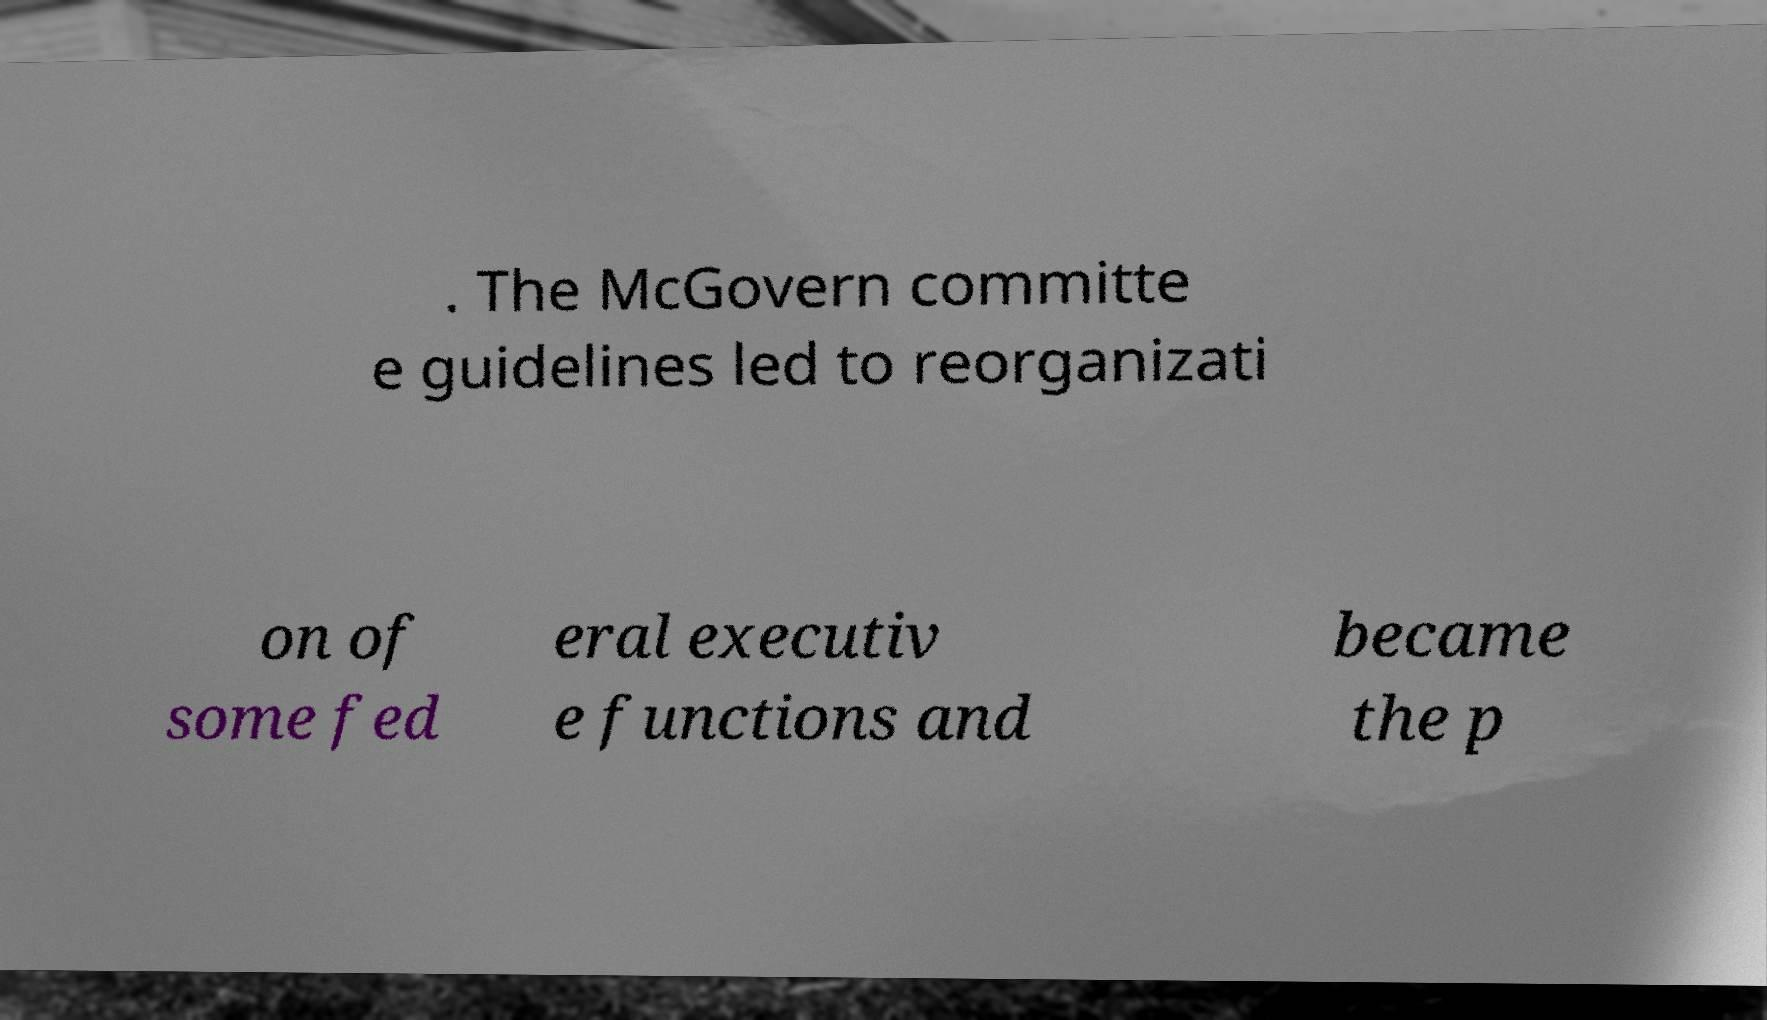Can you accurately transcribe the text from the provided image for me? . The McGovern committe e guidelines led to reorganizati on of some fed eral executiv e functions and became the p 